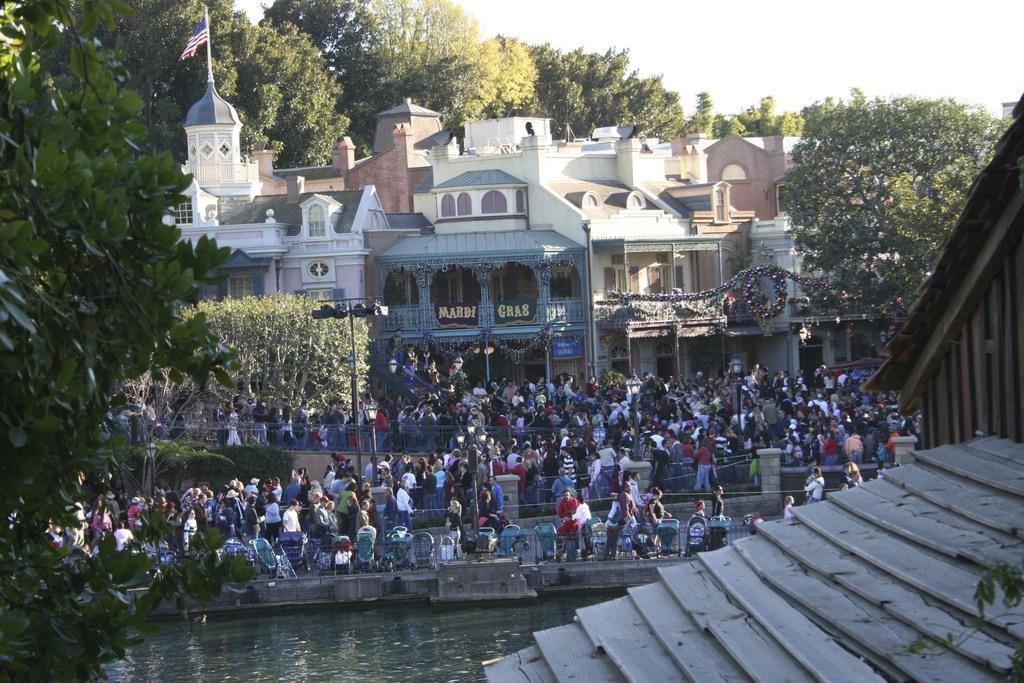Could you give a brief overview of what you see in this image? At the bottom we can see roof and water and on the left there is a tree. In the background there are few persons standing and few are walking on the ground and few are holding strollers in their hands and we can see poles,buildings,name board on the wall,small boards,trees,flag on the building,trees and sky. 